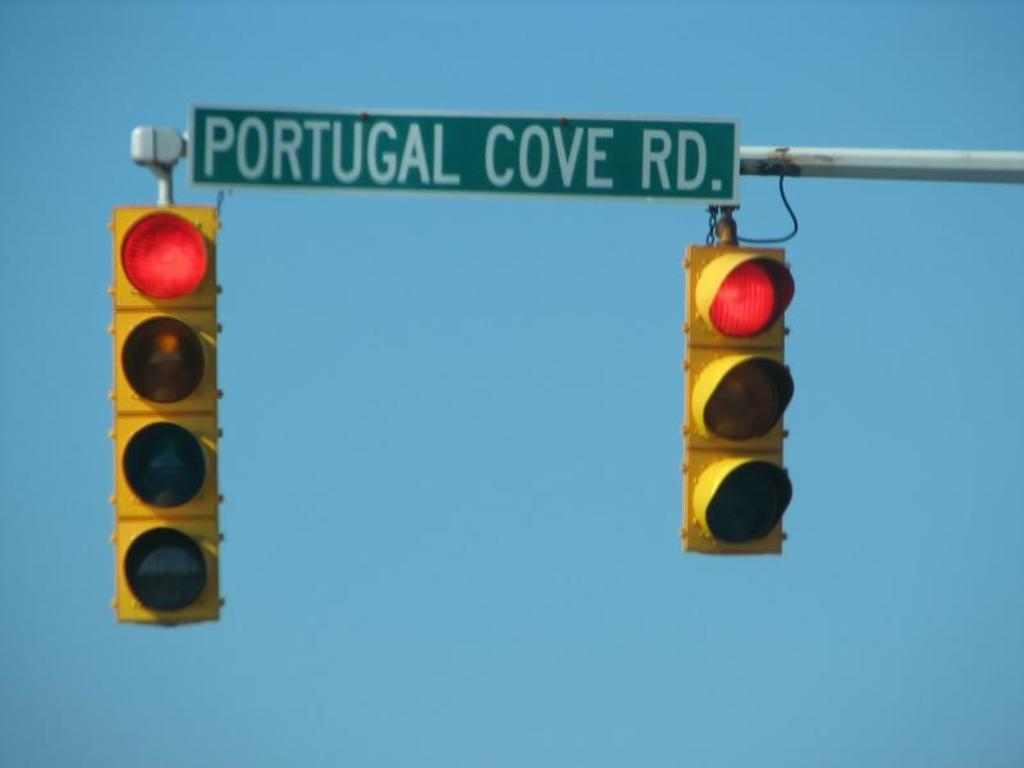<image>
Create a compact narrative representing the image presented. Portugal Cove Road's street sign is above two traffic lights that are on red. 